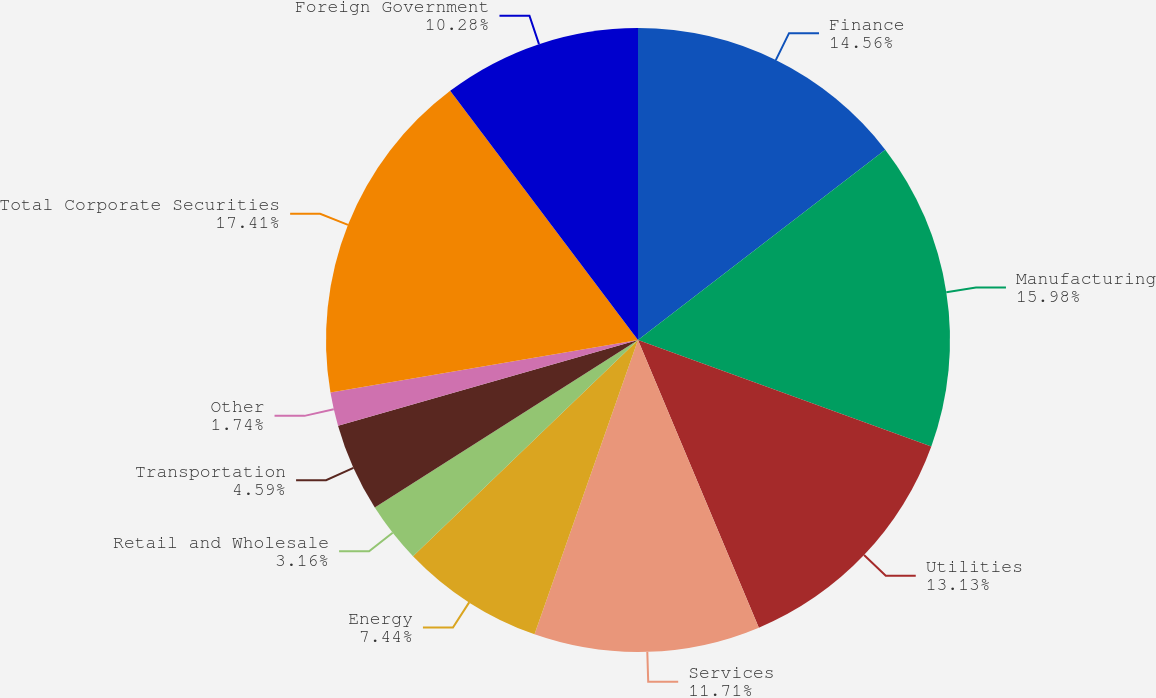Convert chart to OTSL. <chart><loc_0><loc_0><loc_500><loc_500><pie_chart><fcel>Finance<fcel>Manufacturing<fcel>Utilities<fcel>Services<fcel>Energy<fcel>Retail and Wholesale<fcel>Transportation<fcel>Other<fcel>Total Corporate Securities<fcel>Foreign Government<nl><fcel>14.56%<fcel>15.98%<fcel>13.13%<fcel>11.71%<fcel>7.44%<fcel>3.16%<fcel>4.59%<fcel>1.74%<fcel>17.41%<fcel>10.28%<nl></chart> 